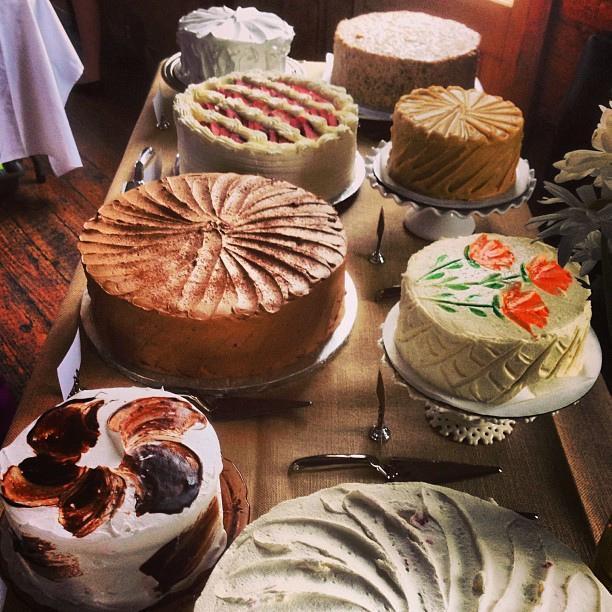How many cakes are there?
Give a very brief answer. 8. How many grey cars are there in the image?
Give a very brief answer. 0. 